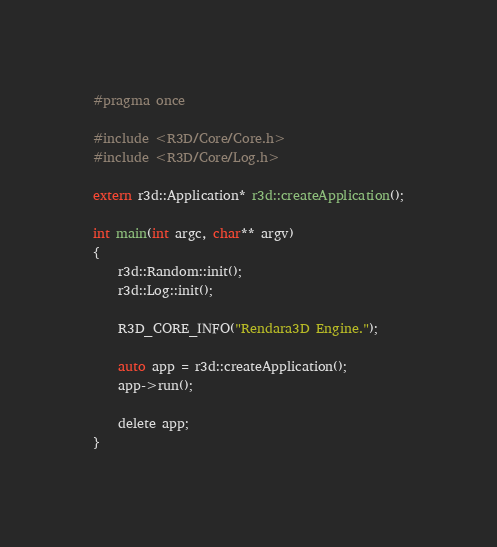<code> <loc_0><loc_0><loc_500><loc_500><_C_>#pragma once

#include <R3D/Core/Core.h>
#include <R3D/Core/Log.h>

extern r3d::Application* r3d::createApplication();

int main(int argc, char** argv)
{
	r3d::Random::init();
	r3d::Log::init();

	R3D_CORE_INFO("Rendara3D Engine.");

	auto app = r3d::createApplication();
	app->run();

	delete app;
}

</code> 